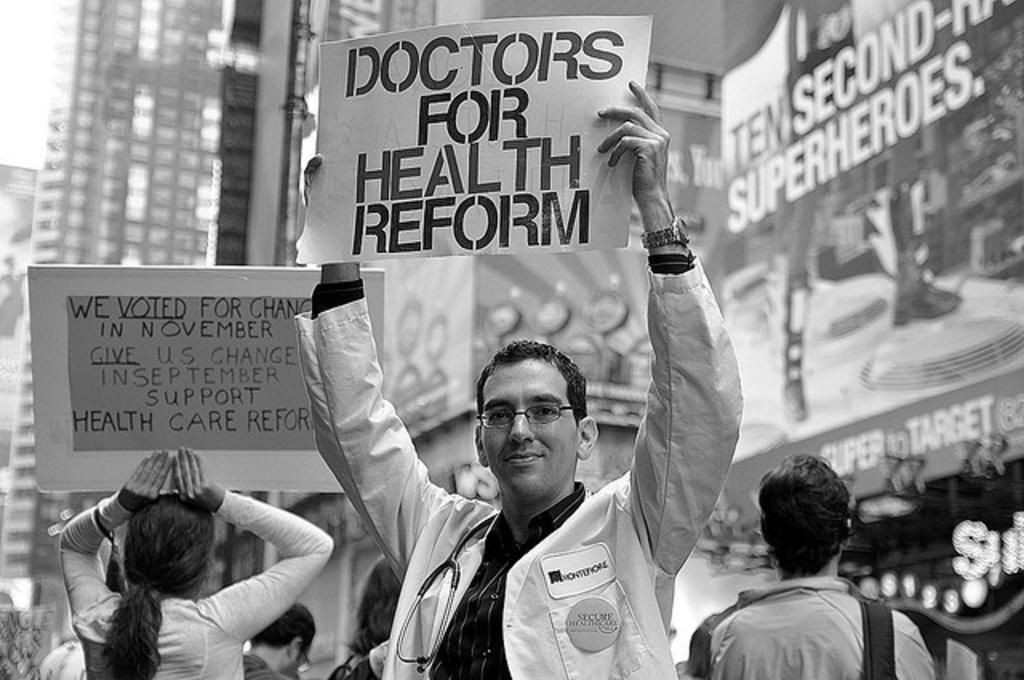How many people are in the group that is visible in the image? There is a group of people in the image, but the exact number is not specified. What are some people in the group holding? Some people in the group are holding a cardboard. What can be seen on the cardboard? There is writing on the cardboard. What can be seen in the distance behind the group? There are buildings in the background of the image. What type of beetle can be seen crawling in the garden in the image? There is no beetle or garden present in the image; it features a group of people with a cardboard and buildings in the background. 